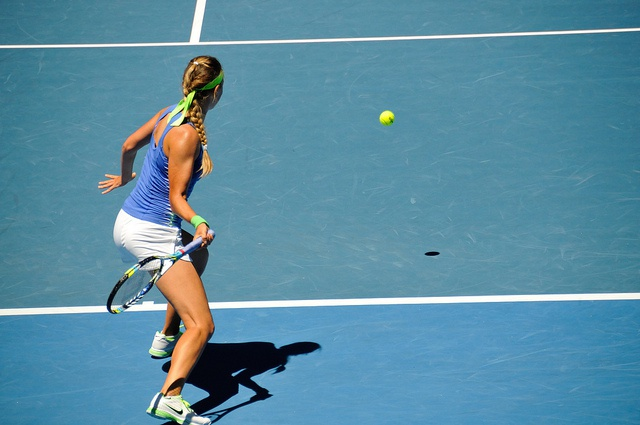Describe the objects in this image and their specific colors. I can see people in teal, orange, black, white, and lightblue tones, tennis racket in teal, gray, lightgray, and black tones, and sports ball in teal, yellow, green, and khaki tones in this image. 